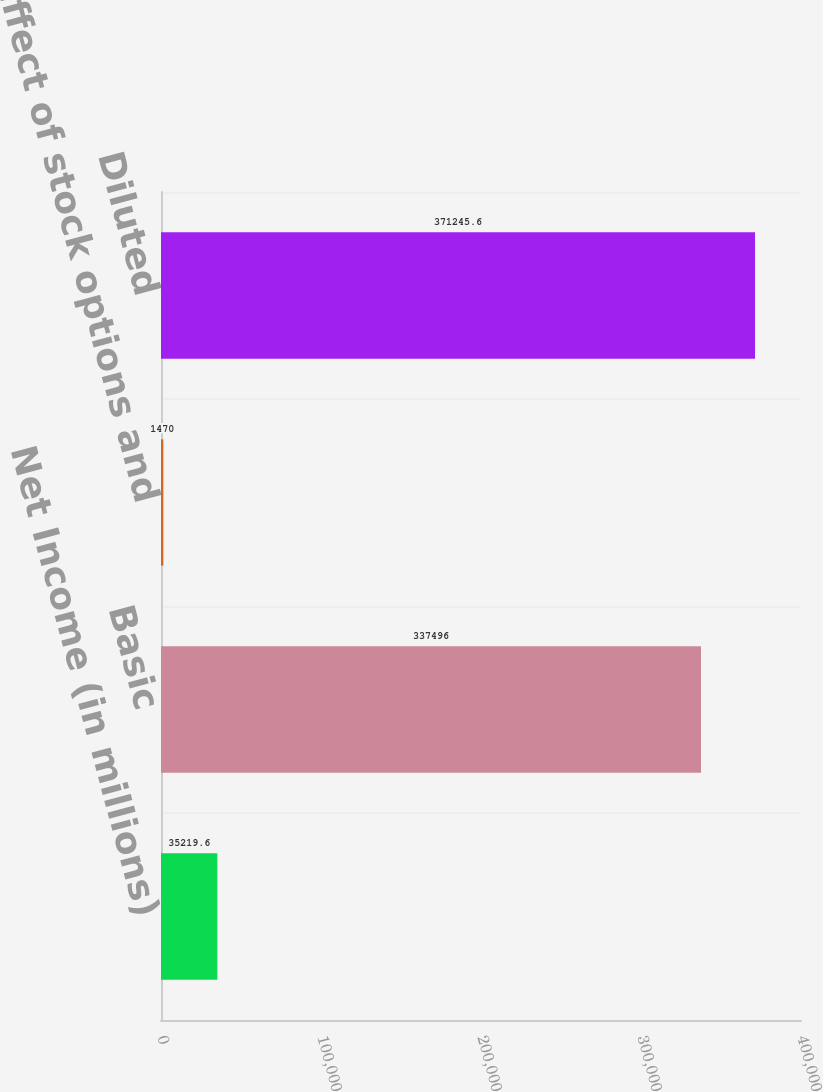Convert chart to OTSL. <chart><loc_0><loc_0><loc_500><loc_500><bar_chart><fcel>Net Income (in millions)<fcel>Basic<fcel>Effect of stock options and<fcel>Diluted<nl><fcel>35219.6<fcel>337496<fcel>1470<fcel>371246<nl></chart> 